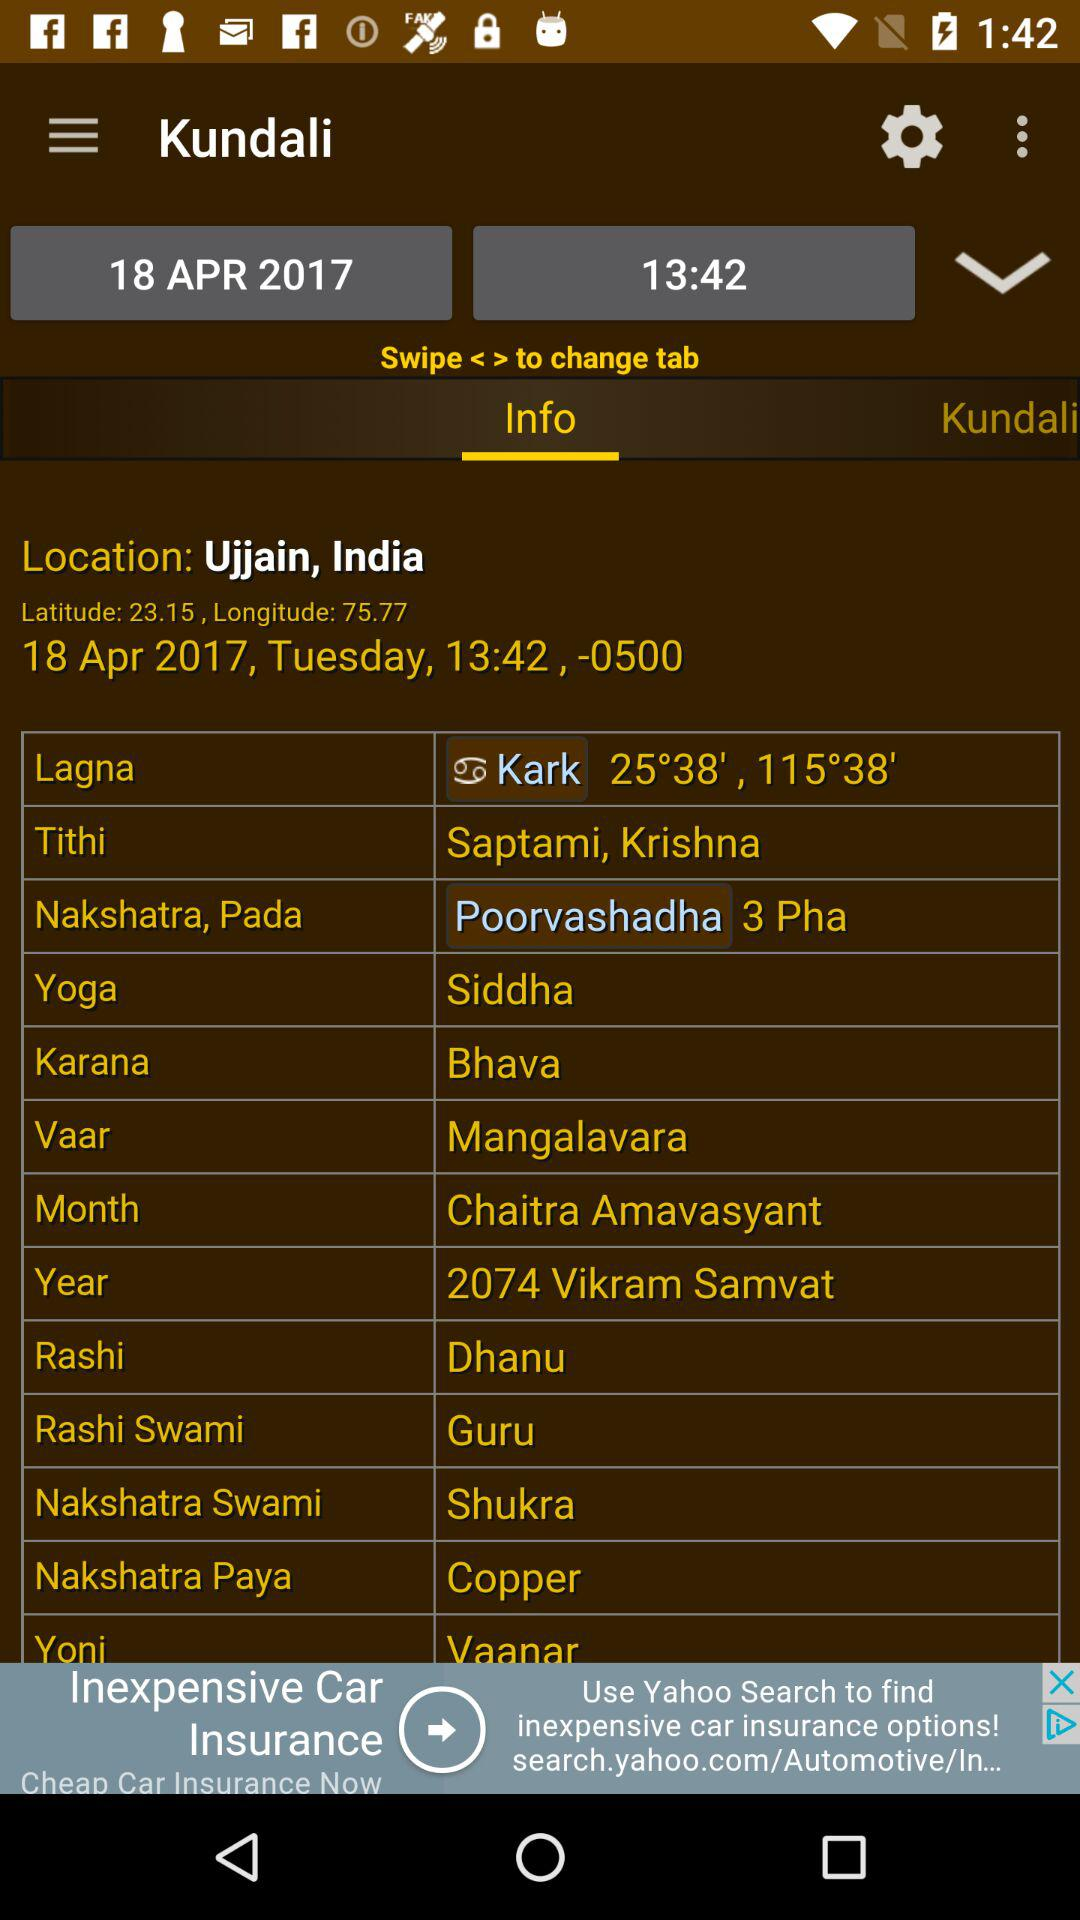What is the selected time? The selected time is 13:42. 